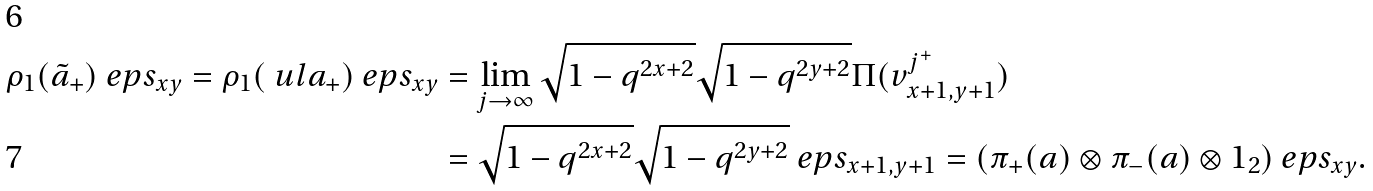Convert formula to latex. <formula><loc_0><loc_0><loc_500><loc_500>\rho _ { 1 } ( \tilde { a } _ { + } ) \ e p s _ { x y } = \rho _ { 1 } ( \ u l a _ { + } ) \ e p s _ { x y } & = \lim _ { j \to \infty } \sqrt { 1 - q ^ { 2 x + 2 } } \sqrt { 1 - q ^ { 2 y + 2 } } \Pi ( v _ { x + 1 , y + 1 } ^ { j ^ { + } } ) \\ & = \sqrt { 1 - q ^ { 2 x + 2 } } \sqrt { 1 - q ^ { 2 y + 2 } } \ e p s _ { x + 1 , y + 1 } = ( \pi _ { + } ( a ) \otimes \pi _ { - } ( a ) \otimes 1 _ { 2 } ) \ e p s _ { x y } .</formula> 